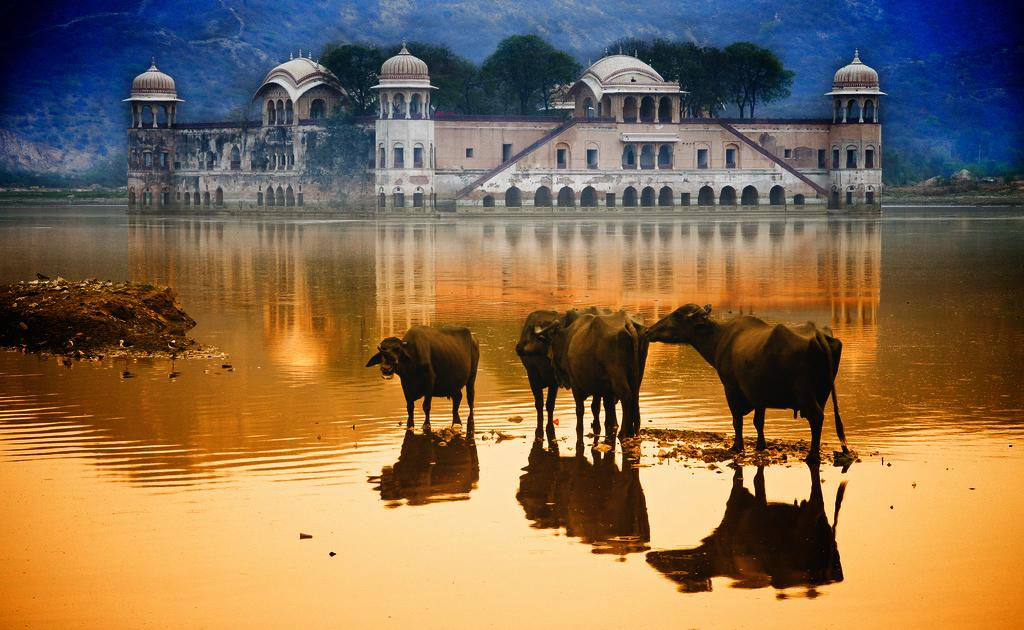What is the main feature in the foreground of the image? There is a sea in the foreground of the image. What animals can be seen in the sea? There are buffaloes in the sea. What can be seen in the background of the image? There is a building, trees, and mountains in the background of the image. What type of alarm is being used by the buffaloes in the image? There is no alarm present in the image; it features buffaloes in the sea. What color is the ink used by the trees in the image? There is no ink present in the image; it features trees in the background. 